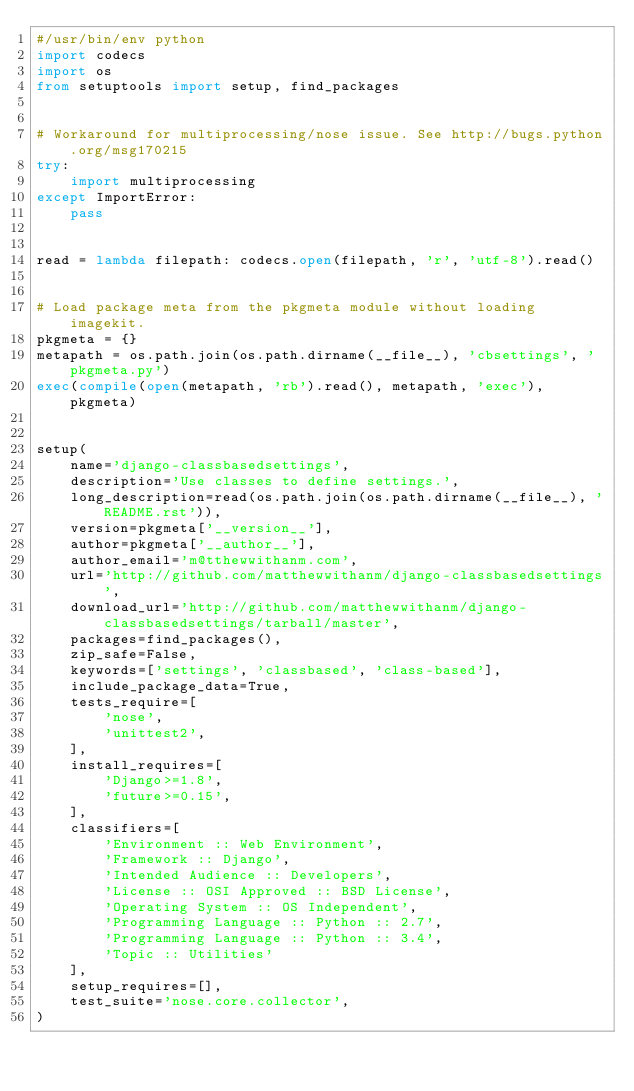Convert code to text. <code><loc_0><loc_0><loc_500><loc_500><_Python_>#/usr/bin/env python
import codecs
import os
from setuptools import setup, find_packages


# Workaround for multiprocessing/nose issue. See http://bugs.python.org/msg170215
try:
    import multiprocessing
except ImportError:
    pass


read = lambda filepath: codecs.open(filepath, 'r', 'utf-8').read()


# Load package meta from the pkgmeta module without loading imagekit.
pkgmeta = {}
metapath = os.path.join(os.path.dirname(__file__), 'cbsettings', 'pkgmeta.py')
exec(compile(open(metapath, 'rb').read(), metapath, 'exec'), pkgmeta)


setup(
    name='django-classbasedsettings',
    description='Use classes to define settings.',
    long_description=read(os.path.join(os.path.dirname(__file__), 'README.rst')),
    version=pkgmeta['__version__'],
    author=pkgmeta['__author__'],
    author_email='m@tthewwithanm.com',
    url='http://github.com/matthewwithanm/django-classbasedsettings',
    download_url='http://github.com/matthewwithanm/django-classbasedsettings/tarball/master',
    packages=find_packages(),
    zip_safe=False,
    keywords=['settings', 'classbased', 'class-based'],
    include_package_data=True,
    tests_require=[
        'nose',
        'unittest2',
    ],
    install_requires=[
        'Django>=1.8',
        'future>=0.15',
    ],
    classifiers=[
        'Environment :: Web Environment',
        'Framework :: Django',
        'Intended Audience :: Developers',
        'License :: OSI Approved :: BSD License',
        'Operating System :: OS Independent',
        'Programming Language :: Python :: 2.7',
        'Programming Language :: Python :: 3.4',
        'Topic :: Utilities'
    ],
    setup_requires=[],
    test_suite='nose.core.collector',
)
</code> 